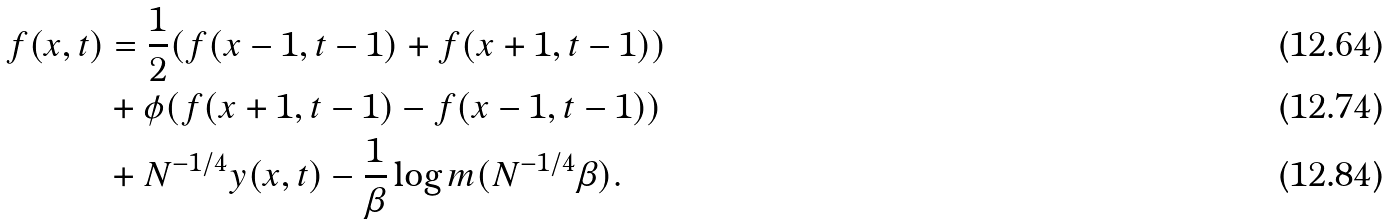Convert formula to latex. <formula><loc_0><loc_0><loc_500><loc_500>f ( x , t ) & = \frac { 1 } { 2 } ( f ( x - 1 , t - 1 ) + f ( x + 1 , t - 1 ) ) \\ & + \phi ( f ( x + 1 , t - 1 ) - f ( x - 1 , t - 1 ) ) \\ & + N ^ { - 1 / 4 } y ( x , t ) - \frac { 1 } { \beta } \log m ( N ^ { - 1 / 4 } \beta ) .</formula> 